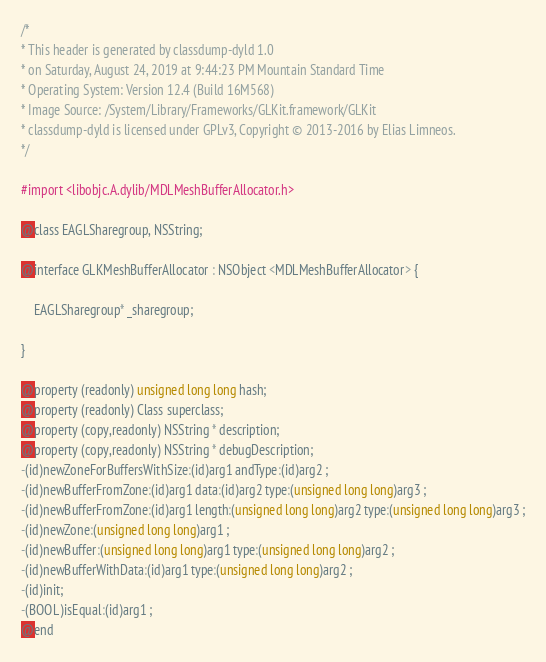Convert code to text. <code><loc_0><loc_0><loc_500><loc_500><_C_>/*
* This header is generated by classdump-dyld 1.0
* on Saturday, August 24, 2019 at 9:44:23 PM Mountain Standard Time
* Operating System: Version 12.4 (Build 16M568)
* Image Source: /System/Library/Frameworks/GLKit.framework/GLKit
* classdump-dyld is licensed under GPLv3, Copyright © 2013-2016 by Elias Limneos.
*/

#import <libobjc.A.dylib/MDLMeshBufferAllocator.h>

@class EAGLSharegroup, NSString;

@interface GLKMeshBufferAllocator : NSObject <MDLMeshBufferAllocator> {

	EAGLSharegroup* _sharegroup;

}

@property (readonly) unsigned long long hash; 
@property (readonly) Class superclass; 
@property (copy,readonly) NSString * description; 
@property (copy,readonly) NSString * debugDescription; 
-(id)newZoneForBuffersWithSize:(id)arg1 andType:(id)arg2 ;
-(id)newBufferFromZone:(id)arg1 data:(id)arg2 type:(unsigned long long)arg3 ;
-(id)newBufferFromZone:(id)arg1 length:(unsigned long long)arg2 type:(unsigned long long)arg3 ;
-(id)newZone:(unsigned long long)arg1 ;
-(id)newBuffer:(unsigned long long)arg1 type:(unsigned long long)arg2 ;
-(id)newBufferWithData:(id)arg1 type:(unsigned long long)arg2 ;
-(id)init;
-(BOOL)isEqual:(id)arg1 ;
@end

</code> 